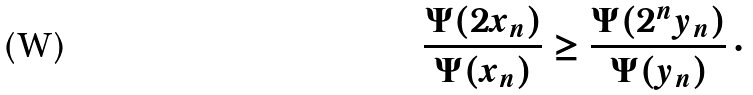<formula> <loc_0><loc_0><loc_500><loc_500>\frac { \Psi ( 2 x _ { n } ) } { \Psi ( x _ { n } ) } \geq \frac { \Psi ( 2 ^ { n } y _ { n } ) } { \Psi ( y _ { n } ) } \, \cdot</formula> 